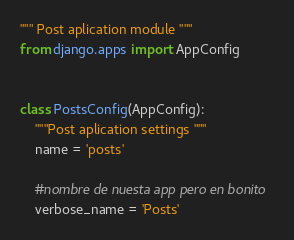Convert code to text. <code><loc_0><loc_0><loc_500><loc_500><_Python_>""" Post aplication module """
from django.apps import AppConfig


class PostsConfig(AppConfig):
    """Post aplication settings """
    name = 'posts'

    #nombre de nuesta app pero en bonito
    verbose_name = 'Posts'
</code> 